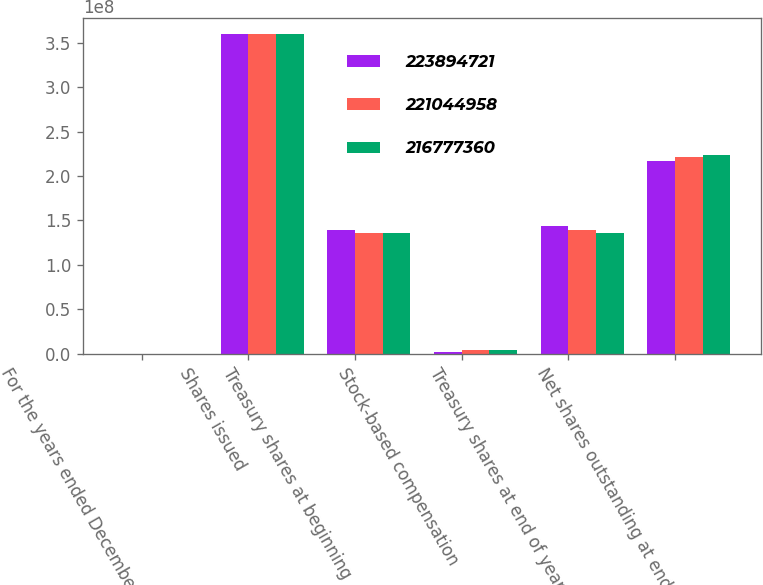Convert chart. <chart><loc_0><loc_0><loc_500><loc_500><stacked_bar_chart><ecel><fcel>For the years ended December<fcel>Shares issued<fcel>Treasury shares at beginning<fcel>Stock-based compensation<fcel>Treasury shares at end of year<fcel>Net shares outstanding at end<nl><fcel>2.23895e+08<fcel>2015<fcel>3.59902e+08<fcel>1.38857e+08<fcel>1.77684e+06<fcel>1.43124e+08<fcel>2.16777e+08<nl><fcel>2.21045e+08<fcel>2014<fcel>3.59902e+08<fcel>1.36007e+08<fcel>3.67651e+06<fcel>1.38857e+08<fcel>2.21045e+08<nl><fcel>2.16777e+08<fcel>2013<fcel>3.59902e+08<fcel>1.36116e+08<fcel>3.65583e+06<fcel>1.36007e+08<fcel>2.23895e+08<nl></chart> 